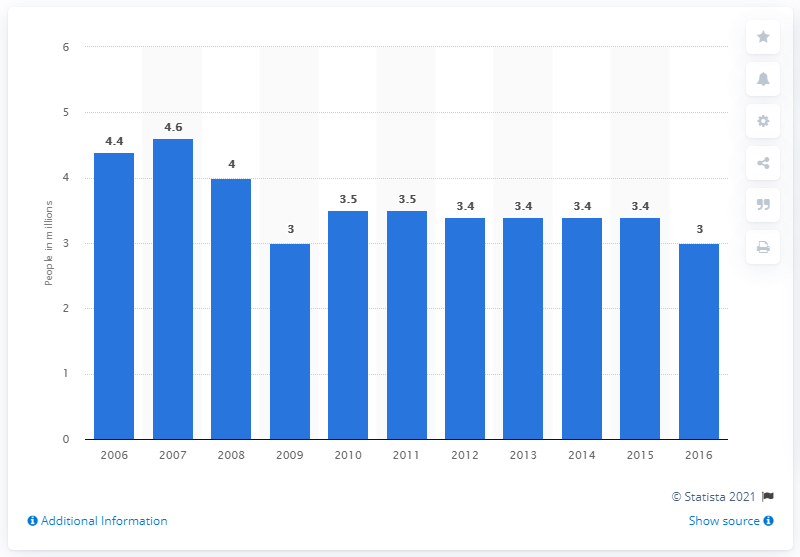Indicate a few pertinent items in this graphic. In 2015, Manpower Group placed a total of 3.4 people in permanent, temporary, and contract positions. 